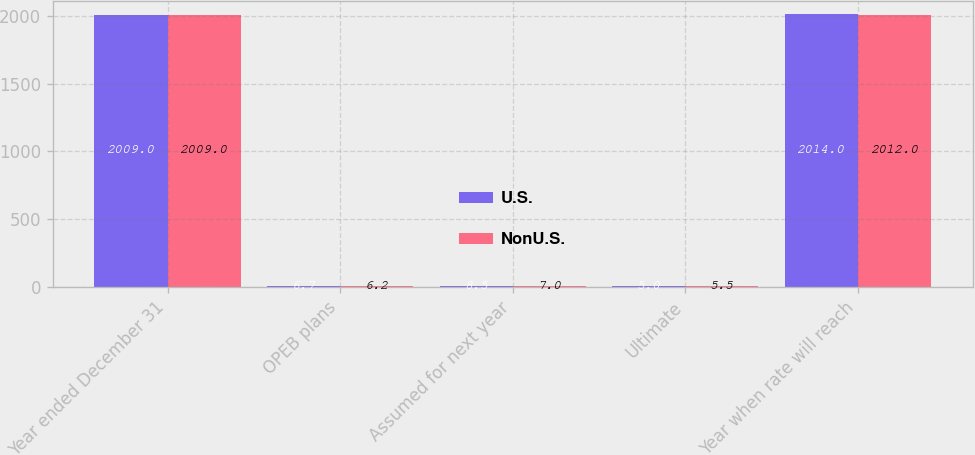<chart> <loc_0><loc_0><loc_500><loc_500><stacked_bar_chart><ecel><fcel>Year ended December 31<fcel>OPEB plans<fcel>Assumed for next year<fcel>Ultimate<fcel>Year when rate will reach<nl><fcel>U.S.<fcel>2009<fcel>6.7<fcel>8.5<fcel>5<fcel>2014<nl><fcel>NonU.S.<fcel>2009<fcel>6.2<fcel>7<fcel>5.5<fcel>2012<nl></chart> 